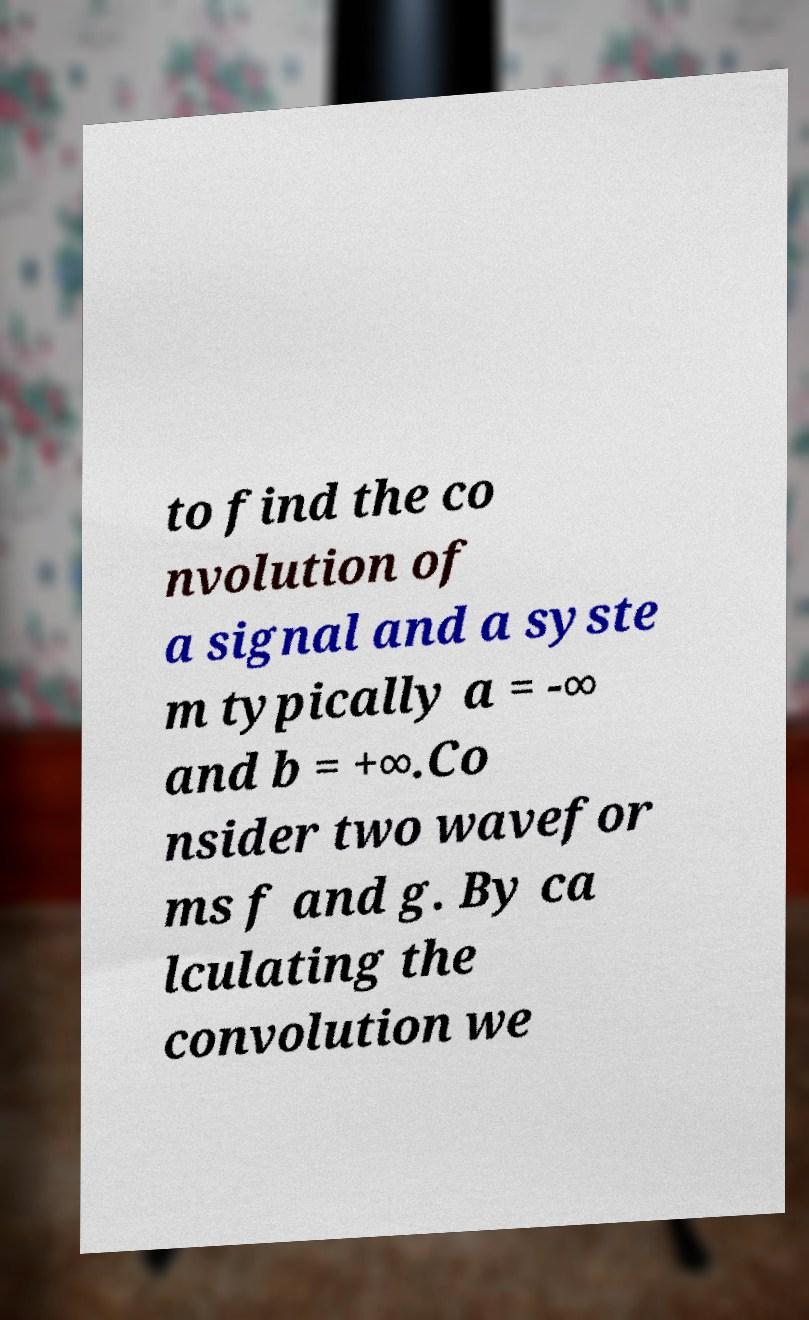Could you extract and type out the text from this image? to find the co nvolution of a signal and a syste m typically a = -∞ and b = +∞.Co nsider two wavefor ms f and g. By ca lculating the convolution we 